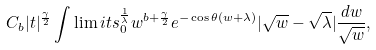<formula> <loc_0><loc_0><loc_500><loc_500>C _ { b } | t | ^ { \frac { \gamma } { 2 } } \int \lim i t s _ { 0 } ^ { \frac { 1 } { \lambda } } w ^ { b + \frac { \gamma } { 2 } } e ^ { - \cos \theta ( w + \lambda ) } | \sqrt { w } - \sqrt { \lambda } | \frac { d w } { \sqrt { w } } ,</formula> 